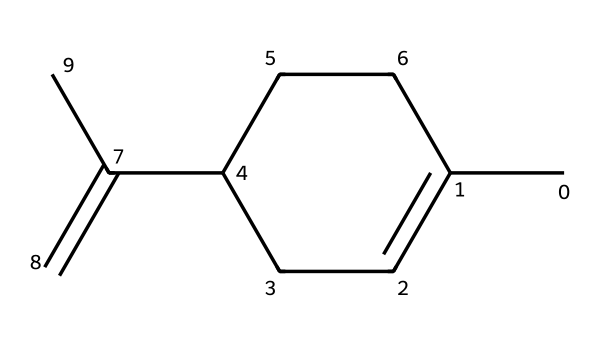What is the chemical name of the compound represented by this SMILES? The SMILES representation corresponds to a common structure for limonene, which is well documented in chemical literature.
Answer: limonene How many carbon atoms are in the structure? By analyzing the SMILES, each letter "C" represents a carbon atom; counting them gives a total of 10 carbon atoms in the structure.
Answer: 10 What type of geometrical arrangement does this chiral compound exhibit? The presence of asymmetric carbon centers indicates that the compound can exhibit enantiomeric forms, leading to a chiral arrangement.
Answer: chiral How many double bonds are present in limonene? The structure shown has one instance of a double bond (C=C), as indicated by the "=" symbol in the SMILES notation, resulting in a total of one double bond.
Answer: 1 Which specific chiral centers are present in this limonene structure? Chiral centers are defined by carbon atoms bonded to four different substituents; the structure derived from this SMILES contains two such chiral centers.
Answer: 2 How does limonene's chirality affect its odor? Limonene exists as two enantiomers, R-limonene and S-limonene, each imparting different scents due to their unique spatial arrangements affecting interactions with olfactory receptors.
Answer: different scents 